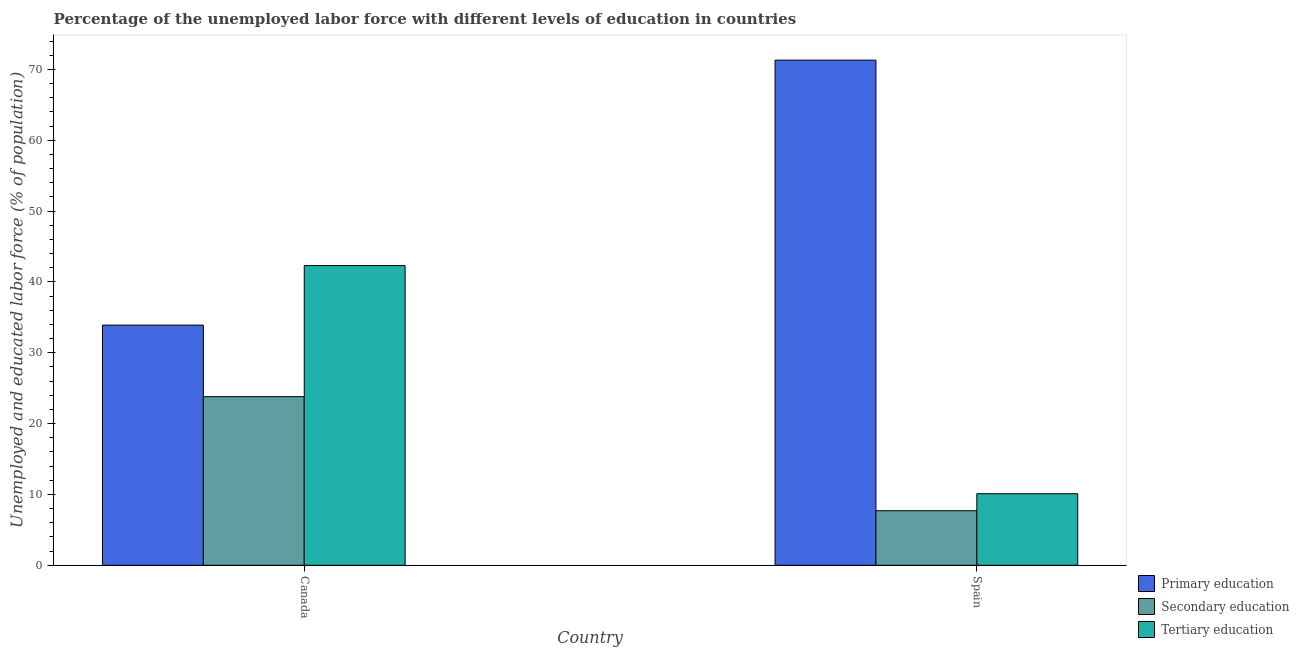How many groups of bars are there?
Give a very brief answer. 2. Are the number of bars on each tick of the X-axis equal?
Ensure brevity in your answer.  Yes. How many bars are there on the 2nd tick from the left?
Make the answer very short. 3. What is the label of the 2nd group of bars from the left?
Your answer should be very brief. Spain. What is the percentage of labor force who received secondary education in Canada?
Keep it short and to the point. 23.8. Across all countries, what is the maximum percentage of labor force who received tertiary education?
Make the answer very short. 42.3. Across all countries, what is the minimum percentage of labor force who received tertiary education?
Offer a very short reply. 10.1. In which country was the percentage of labor force who received tertiary education maximum?
Make the answer very short. Canada. What is the total percentage of labor force who received tertiary education in the graph?
Your answer should be very brief. 52.4. What is the difference between the percentage of labor force who received tertiary education in Canada and that in Spain?
Give a very brief answer. 32.2. What is the difference between the percentage of labor force who received secondary education in Canada and the percentage of labor force who received primary education in Spain?
Provide a succinct answer. -47.5. What is the average percentage of labor force who received secondary education per country?
Provide a short and direct response. 15.75. What is the difference between the percentage of labor force who received primary education and percentage of labor force who received tertiary education in Canada?
Ensure brevity in your answer.  -8.4. In how many countries, is the percentage of labor force who received primary education greater than 36 %?
Offer a terse response. 1. What is the ratio of the percentage of labor force who received secondary education in Canada to that in Spain?
Your answer should be compact. 3.09. Is the percentage of labor force who received primary education in Canada less than that in Spain?
Keep it short and to the point. Yes. In how many countries, is the percentage of labor force who received tertiary education greater than the average percentage of labor force who received tertiary education taken over all countries?
Your answer should be compact. 1. What does the 2nd bar from the right in Canada represents?
Your answer should be compact. Secondary education. Is it the case that in every country, the sum of the percentage of labor force who received primary education and percentage of labor force who received secondary education is greater than the percentage of labor force who received tertiary education?
Ensure brevity in your answer.  Yes. Are all the bars in the graph horizontal?
Offer a terse response. No. What is the difference between two consecutive major ticks on the Y-axis?
Make the answer very short. 10. Does the graph contain any zero values?
Provide a short and direct response. No. Where does the legend appear in the graph?
Give a very brief answer. Bottom right. How many legend labels are there?
Your response must be concise. 3. How are the legend labels stacked?
Offer a very short reply. Vertical. What is the title of the graph?
Your answer should be compact. Percentage of the unemployed labor force with different levels of education in countries. What is the label or title of the X-axis?
Ensure brevity in your answer.  Country. What is the label or title of the Y-axis?
Give a very brief answer. Unemployed and educated labor force (% of population). What is the Unemployed and educated labor force (% of population) of Primary education in Canada?
Keep it short and to the point. 33.9. What is the Unemployed and educated labor force (% of population) in Secondary education in Canada?
Offer a terse response. 23.8. What is the Unemployed and educated labor force (% of population) in Tertiary education in Canada?
Give a very brief answer. 42.3. What is the Unemployed and educated labor force (% of population) in Primary education in Spain?
Your answer should be compact. 71.3. What is the Unemployed and educated labor force (% of population) in Secondary education in Spain?
Your response must be concise. 7.7. What is the Unemployed and educated labor force (% of population) in Tertiary education in Spain?
Ensure brevity in your answer.  10.1. Across all countries, what is the maximum Unemployed and educated labor force (% of population) of Primary education?
Ensure brevity in your answer.  71.3. Across all countries, what is the maximum Unemployed and educated labor force (% of population) in Secondary education?
Your response must be concise. 23.8. Across all countries, what is the maximum Unemployed and educated labor force (% of population) of Tertiary education?
Ensure brevity in your answer.  42.3. Across all countries, what is the minimum Unemployed and educated labor force (% of population) in Primary education?
Keep it short and to the point. 33.9. Across all countries, what is the minimum Unemployed and educated labor force (% of population) in Secondary education?
Your response must be concise. 7.7. Across all countries, what is the minimum Unemployed and educated labor force (% of population) of Tertiary education?
Provide a succinct answer. 10.1. What is the total Unemployed and educated labor force (% of population) of Primary education in the graph?
Ensure brevity in your answer.  105.2. What is the total Unemployed and educated labor force (% of population) in Secondary education in the graph?
Keep it short and to the point. 31.5. What is the total Unemployed and educated labor force (% of population) in Tertiary education in the graph?
Your answer should be very brief. 52.4. What is the difference between the Unemployed and educated labor force (% of population) in Primary education in Canada and that in Spain?
Your response must be concise. -37.4. What is the difference between the Unemployed and educated labor force (% of population) in Secondary education in Canada and that in Spain?
Offer a terse response. 16.1. What is the difference between the Unemployed and educated labor force (% of population) in Tertiary education in Canada and that in Spain?
Make the answer very short. 32.2. What is the difference between the Unemployed and educated labor force (% of population) in Primary education in Canada and the Unemployed and educated labor force (% of population) in Secondary education in Spain?
Give a very brief answer. 26.2. What is the difference between the Unemployed and educated labor force (% of population) in Primary education in Canada and the Unemployed and educated labor force (% of population) in Tertiary education in Spain?
Ensure brevity in your answer.  23.8. What is the difference between the Unemployed and educated labor force (% of population) of Secondary education in Canada and the Unemployed and educated labor force (% of population) of Tertiary education in Spain?
Your answer should be compact. 13.7. What is the average Unemployed and educated labor force (% of population) of Primary education per country?
Make the answer very short. 52.6. What is the average Unemployed and educated labor force (% of population) in Secondary education per country?
Your response must be concise. 15.75. What is the average Unemployed and educated labor force (% of population) in Tertiary education per country?
Make the answer very short. 26.2. What is the difference between the Unemployed and educated labor force (% of population) of Primary education and Unemployed and educated labor force (% of population) of Secondary education in Canada?
Provide a short and direct response. 10.1. What is the difference between the Unemployed and educated labor force (% of population) of Primary education and Unemployed and educated labor force (% of population) of Tertiary education in Canada?
Provide a short and direct response. -8.4. What is the difference between the Unemployed and educated labor force (% of population) in Secondary education and Unemployed and educated labor force (% of population) in Tertiary education in Canada?
Keep it short and to the point. -18.5. What is the difference between the Unemployed and educated labor force (% of population) in Primary education and Unemployed and educated labor force (% of population) in Secondary education in Spain?
Your answer should be very brief. 63.6. What is the difference between the Unemployed and educated labor force (% of population) of Primary education and Unemployed and educated labor force (% of population) of Tertiary education in Spain?
Provide a short and direct response. 61.2. What is the ratio of the Unemployed and educated labor force (% of population) in Primary education in Canada to that in Spain?
Offer a very short reply. 0.48. What is the ratio of the Unemployed and educated labor force (% of population) in Secondary education in Canada to that in Spain?
Ensure brevity in your answer.  3.09. What is the ratio of the Unemployed and educated labor force (% of population) of Tertiary education in Canada to that in Spain?
Offer a very short reply. 4.19. What is the difference between the highest and the second highest Unemployed and educated labor force (% of population) in Primary education?
Offer a terse response. 37.4. What is the difference between the highest and the second highest Unemployed and educated labor force (% of population) of Secondary education?
Keep it short and to the point. 16.1. What is the difference between the highest and the second highest Unemployed and educated labor force (% of population) of Tertiary education?
Make the answer very short. 32.2. What is the difference between the highest and the lowest Unemployed and educated labor force (% of population) in Primary education?
Ensure brevity in your answer.  37.4. What is the difference between the highest and the lowest Unemployed and educated labor force (% of population) of Secondary education?
Give a very brief answer. 16.1. What is the difference between the highest and the lowest Unemployed and educated labor force (% of population) of Tertiary education?
Offer a terse response. 32.2. 